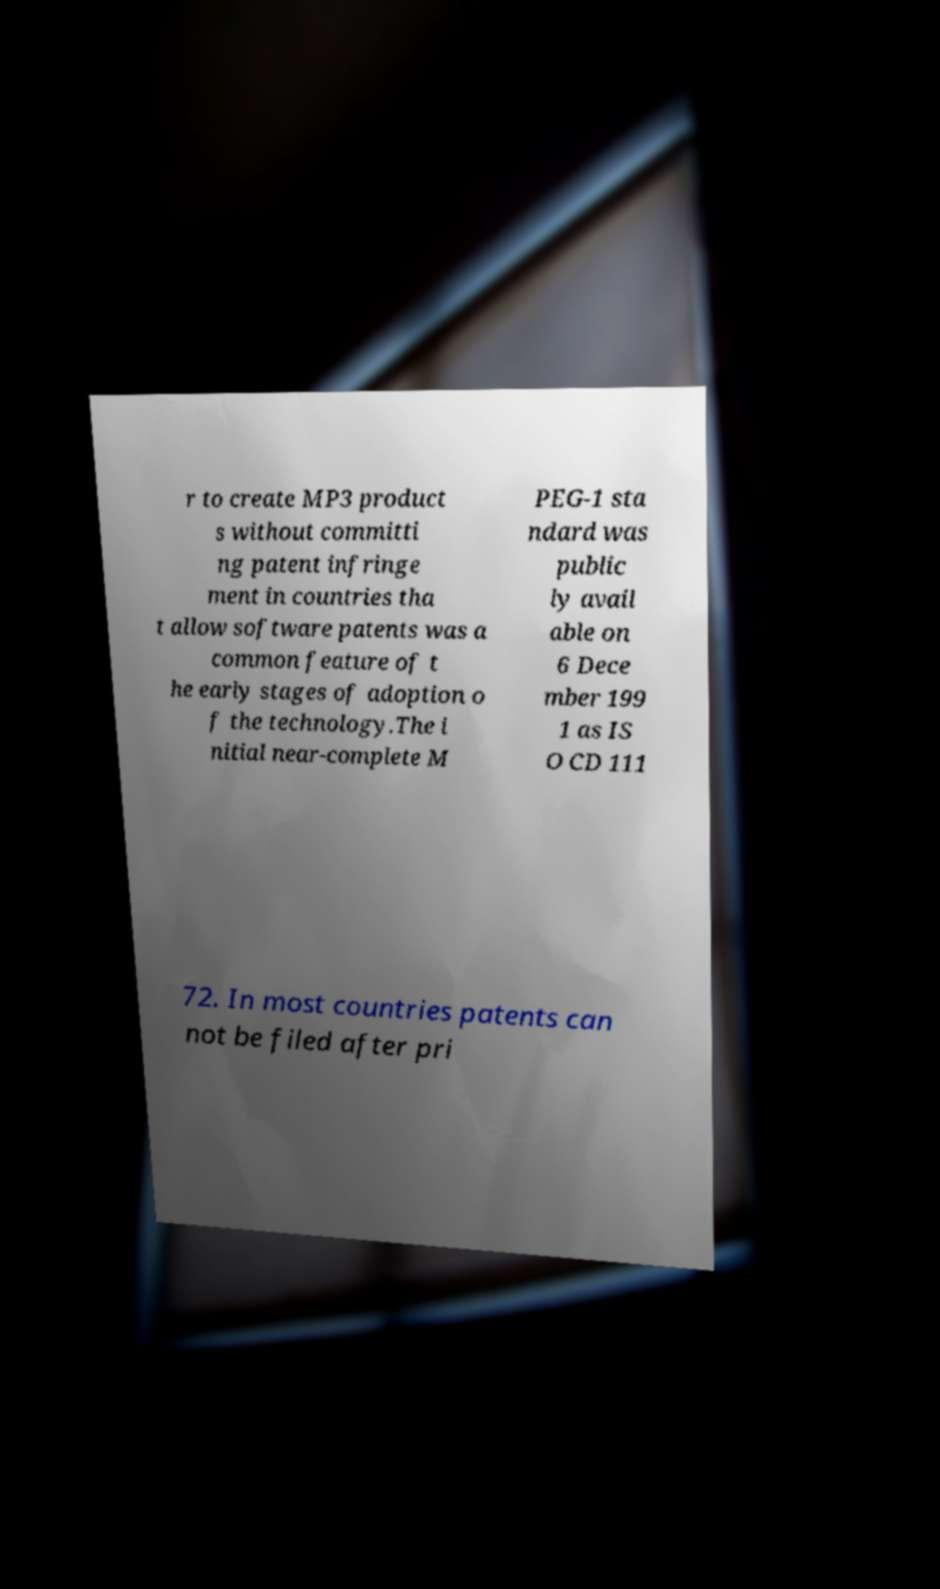Can you read and provide the text displayed in the image?This photo seems to have some interesting text. Can you extract and type it out for me? r to create MP3 product s without committi ng patent infringe ment in countries tha t allow software patents was a common feature of t he early stages of adoption o f the technology.The i nitial near-complete M PEG-1 sta ndard was public ly avail able on 6 Dece mber 199 1 as IS O CD 111 72. In most countries patents can not be filed after pri 